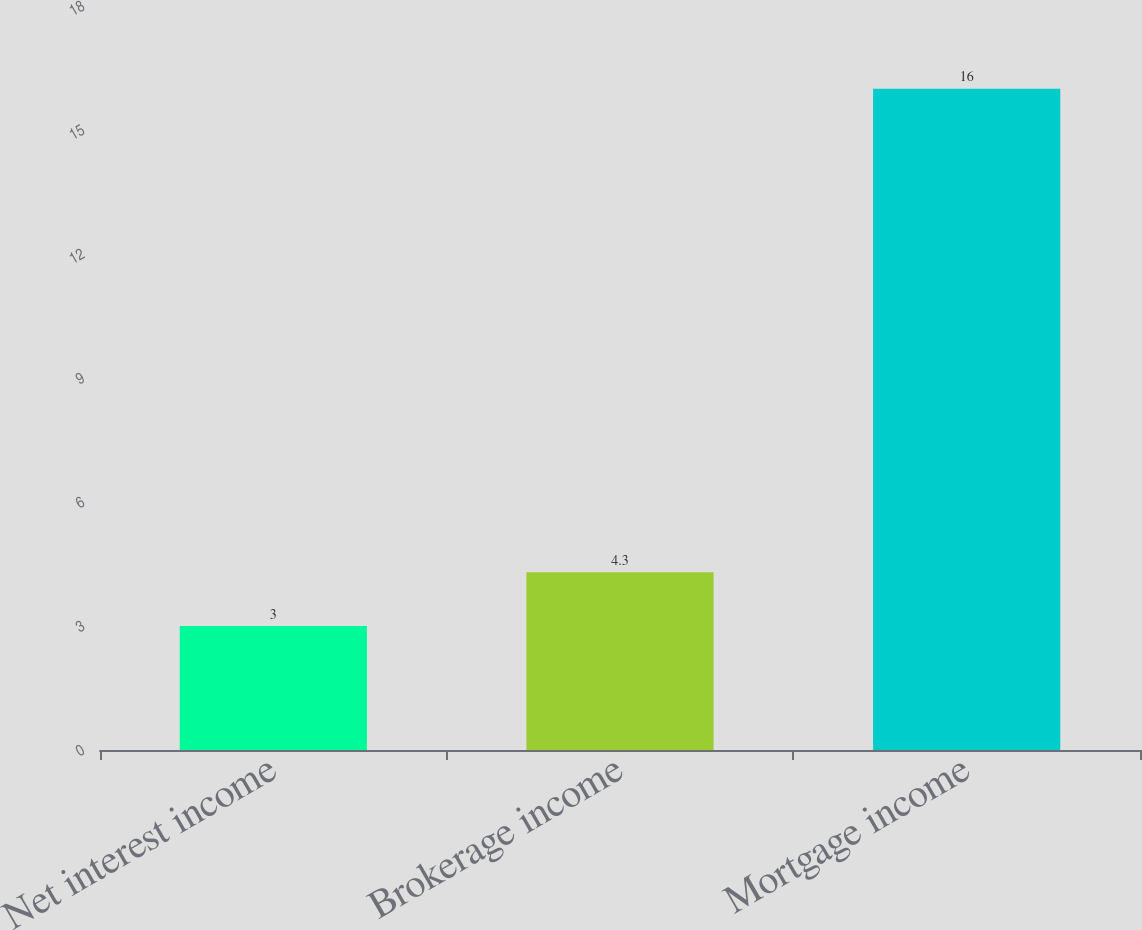Convert chart to OTSL. <chart><loc_0><loc_0><loc_500><loc_500><bar_chart><fcel>Net interest income<fcel>Brokerage income<fcel>Mortgage income<nl><fcel>3<fcel>4.3<fcel>16<nl></chart> 